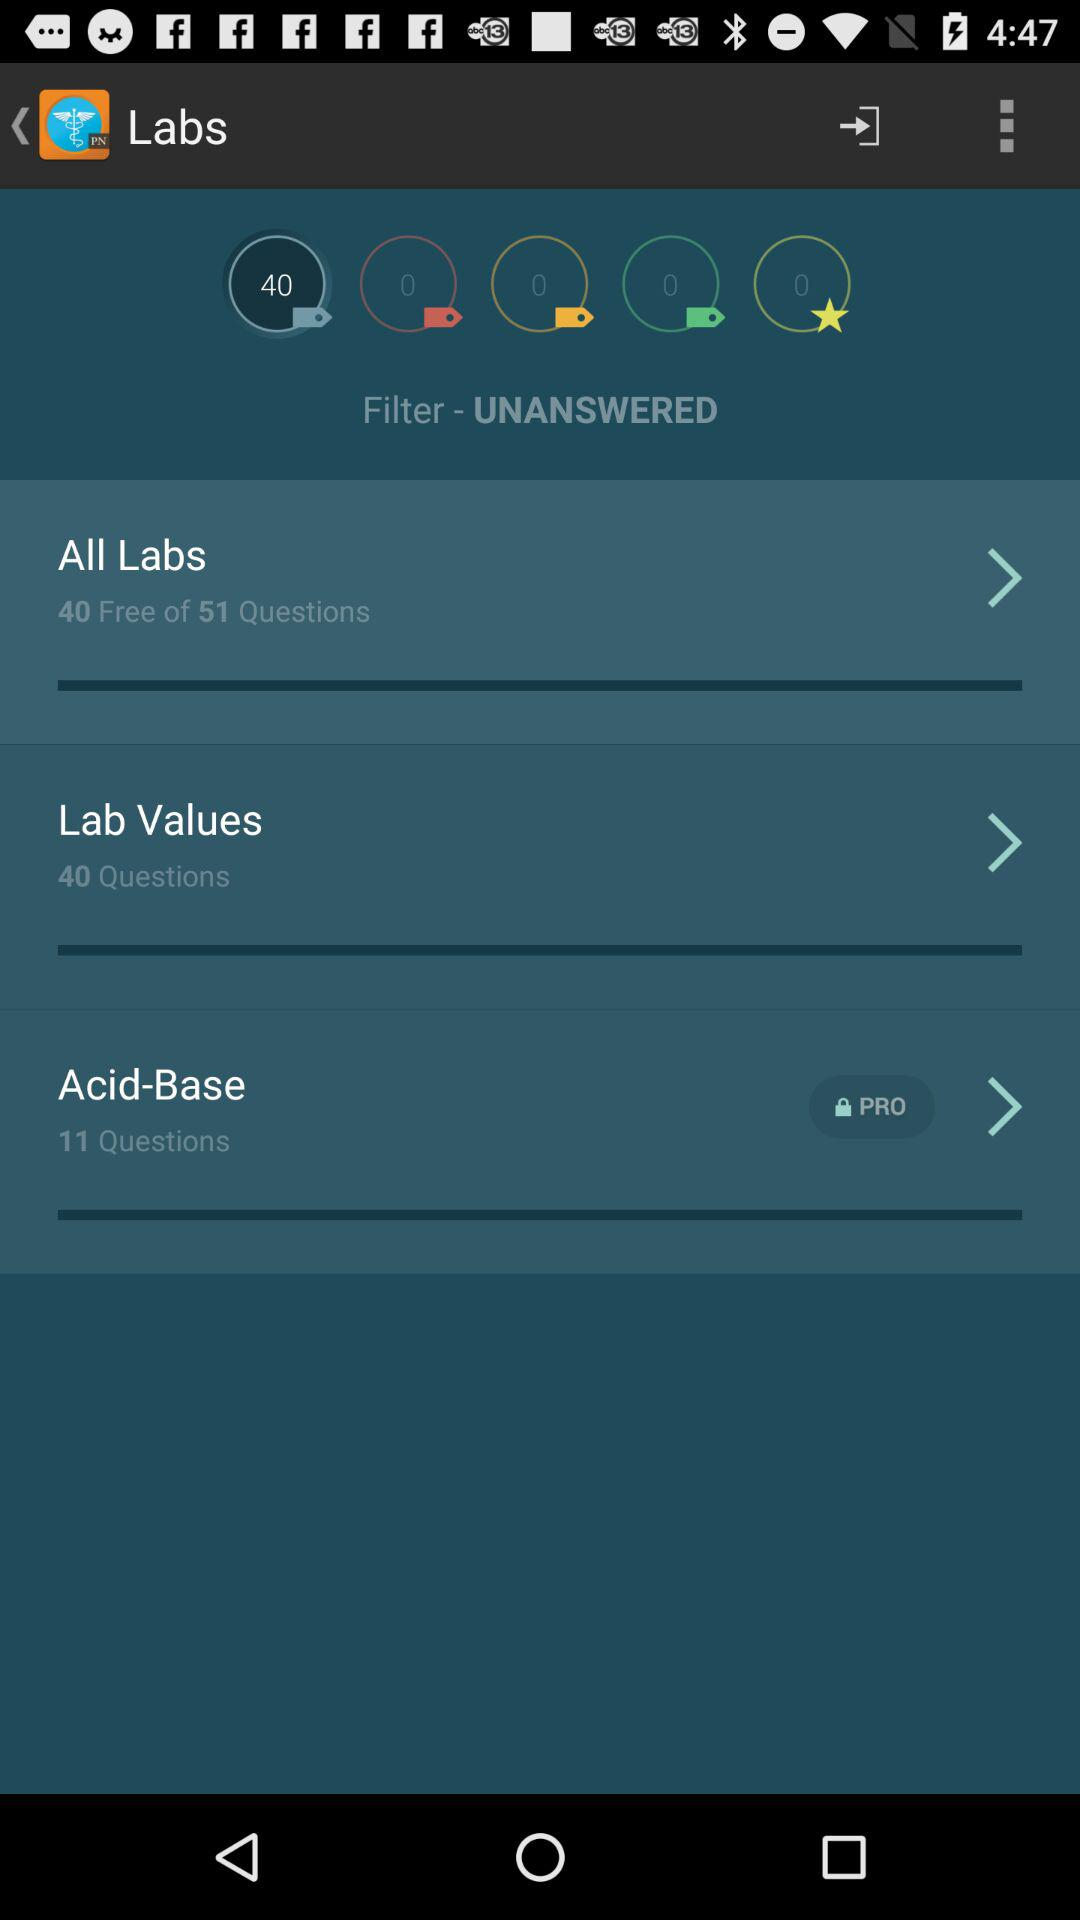What is the total number of questions in "Lab Values"? The total number of questions in "Lab Values" is 40. 